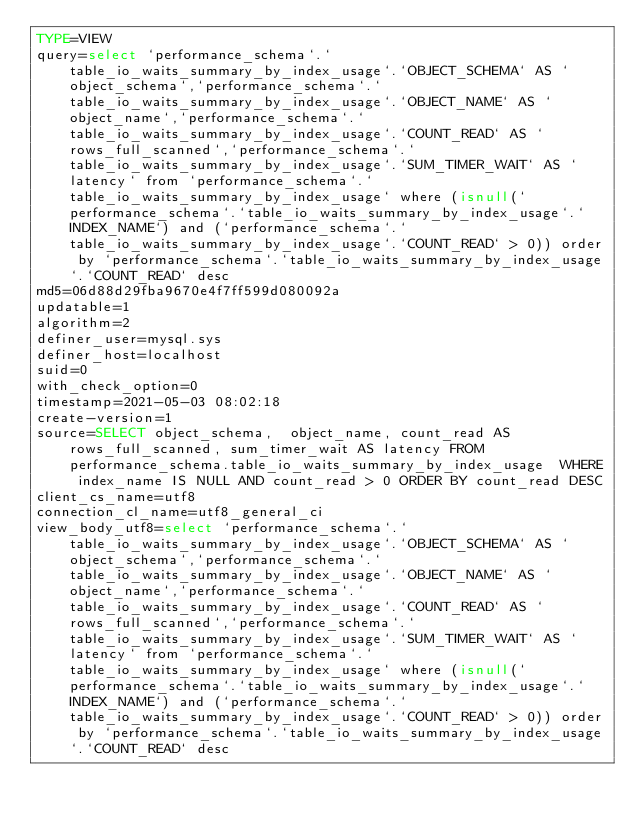Convert code to text. <code><loc_0><loc_0><loc_500><loc_500><_VisualBasic_>TYPE=VIEW
query=select `performance_schema`.`table_io_waits_summary_by_index_usage`.`OBJECT_SCHEMA` AS `object_schema`,`performance_schema`.`table_io_waits_summary_by_index_usage`.`OBJECT_NAME` AS `object_name`,`performance_schema`.`table_io_waits_summary_by_index_usage`.`COUNT_READ` AS `rows_full_scanned`,`performance_schema`.`table_io_waits_summary_by_index_usage`.`SUM_TIMER_WAIT` AS `latency` from `performance_schema`.`table_io_waits_summary_by_index_usage` where (isnull(`performance_schema`.`table_io_waits_summary_by_index_usage`.`INDEX_NAME`) and (`performance_schema`.`table_io_waits_summary_by_index_usage`.`COUNT_READ` > 0)) order by `performance_schema`.`table_io_waits_summary_by_index_usage`.`COUNT_READ` desc
md5=06d88d29fba9670e4f7ff599d080092a
updatable=1
algorithm=2
definer_user=mysql.sys
definer_host=localhost
suid=0
with_check_option=0
timestamp=2021-05-03 08:02:18
create-version=1
source=SELECT object_schema,  object_name, count_read AS rows_full_scanned, sum_timer_wait AS latency FROM performance_schema.table_io_waits_summary_by_index_usage  WHERE index_name IS NULL AND count_read > 0 ORDER BY count_read DESC
client_cs_name=utf8
connection_cl_name=utf8_general_ci
view_body_utf8=select `performance_schema`.`table_io_waits_summary_by_index_usage`.`OBJECT_SCHEMA` AS `object_schema`,`performance_schema`.`table_io_waits_summary_by_index_usage`.`OBJECT_NAME` AS `object_name`,`performance_schema`.`table_io_waits_summary_by_index_usage`.`COUNT_READ` AS `rows_full_scanned`,`performance_schema`.`table_io_waits_summary_by_index_usage`.`SUM_TIMER_WAIT` AS `latency` from `performance_schema`.`table_io_waits_summary_by_index_usage` where (isnull(`performance_schema`.`table_io_waits_summary_by_index_usage`.`INDEX_NAME`) and (`performance_schema`.`table_io_waits_summary_by_index_usage`.`COUNT_READ` > 0)) order by `performance_schema`.`table_io_waits_summary_by_index_usage`.`COUNT_READ` desc
</code> 